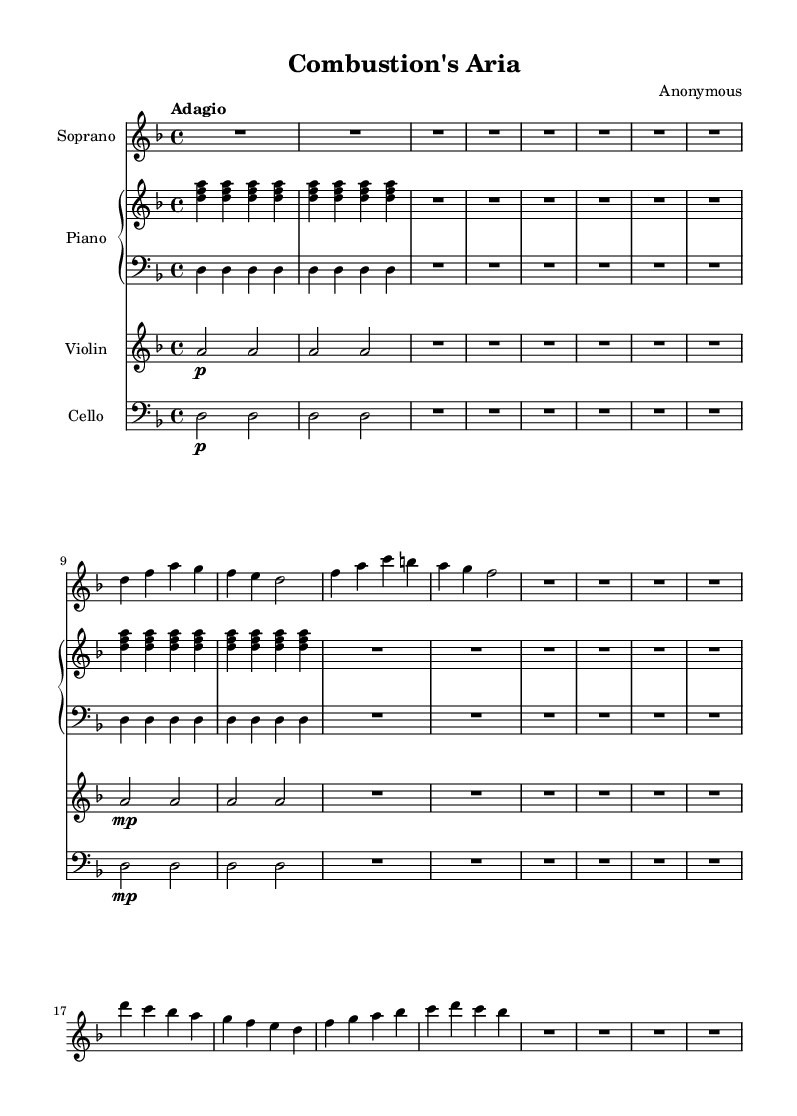What is the key signature of this music? The key signature is indicated at the beginning of the score. It shows two flats, which corresponds to B flat and E flat. Therefore, this is the key of D minor.
Answer: D minor What is the time signature of this music? The time signature is found at the beginning of the score, after the key signature. It shows a "4/4" signature, meaning there are four beats in each measure and a quarter note gets one beat.
Answer: 4/4 What is the tempo marking in this music? The tempo marking is usually written above the staff at the start of the piece. It says "Adagio," which indicates a slow and leisurely pace.
Answer: Adagio How many measures are present in the soprano line? To determine the number of measures in the soprano line, we count the vertical lines that separate the measures. The soprano section consists of 8 measures.
Answer: 8 Which instruments are featured in this score? The instruments can be identified by the staff names at the beginning of each part. The featured instruments are soprano, piano, violin, and cello.
Answer: Soprano, piano, violin, cello What is the dynamic marking for the violin part in the first segment? The dynamic marking is notated directly in the violin part. It shows "p" indicating it should be played piano, or softly, during this section.
Answer: Piano Which musical term describes the overall style of this piece? The term associated with operatic music is "aria," which refers to a solo performance in an opera, typically expressing emotion or reflection. This is indicated by the title "Combustion's Aria."
Answer: Aria 